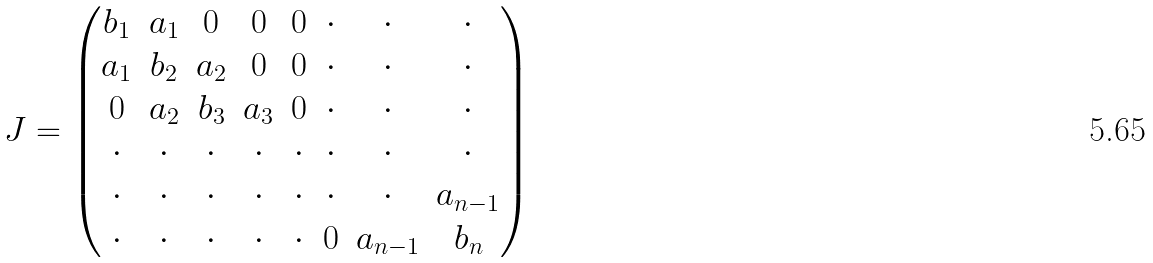Convert formula to latex. <formula><loc_0><loc_0><loc_500><loc_500>J = \begin{pmatrix} b _ { 1 } & a _ { 1 } & 0 & 0 & 0 & \cdot & \cdot & \cdot \\ a _ { 1 } & b _ { 2 } & a _ { 2 } & 0 & 0 & \cdot & \cdot & \cdot \\ 0 & a _ { 2 } & b _ { 3 } & a _ { 3 } & 0 & \cdot & \cdot & \cdot \\ \cdot & \cdot & \cdot & \cdot & \cdot & \cdot & \cdot & \cdot \\ \cdot & \cdot & \cdot & \cdot & \cdot & \cdot & \cdot & a _ { n - 1 } \\ \cdot & \cdot & \cdot & \cdot & \cdot & 0 & a _ { n - 1 } & b _ { n } \end{pmatrix}</formula> 